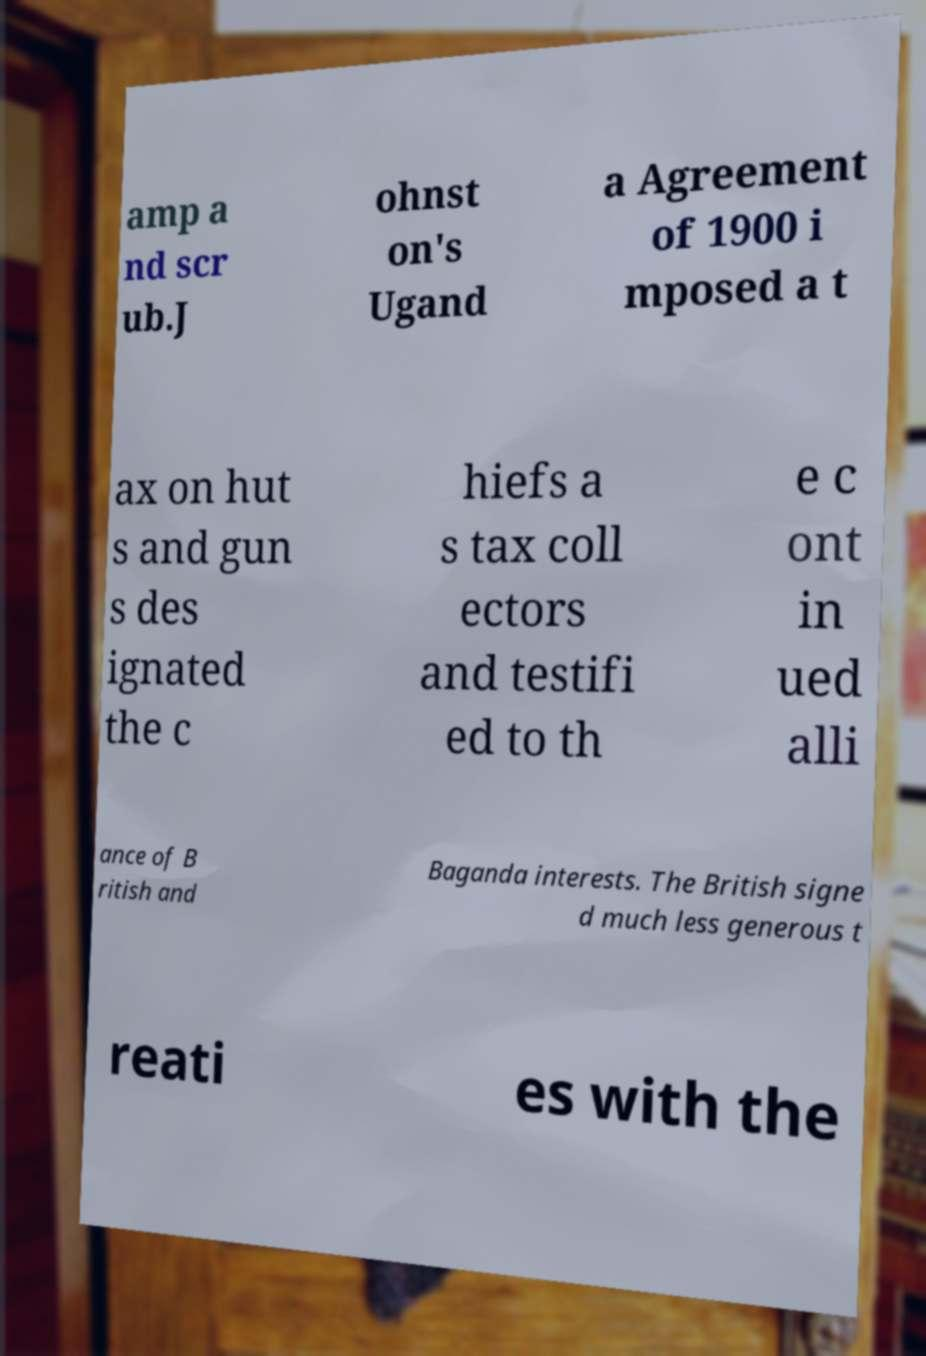Can you accurately transcribe the text from the provided image for me? amp a nd scr ub.J ohnst on's Ugand a Agreement of 1900 i mposed a t ax on hut s and gun s des ignated the c hiefs a s tax coll ectors and testifi ed to th e c ont in ued alli ance of B ritish and Baganda interests. The British signe d much less generous t reati es with the 